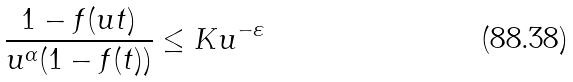<formula> <loc_0><loc_0><loc_500><loc_500>\frac { 1 - f ( u t ) } { u ^ { \alpha } ( 1 - f ( t ) ) } \leq K u ^ { - \varepsilon }</formula> 